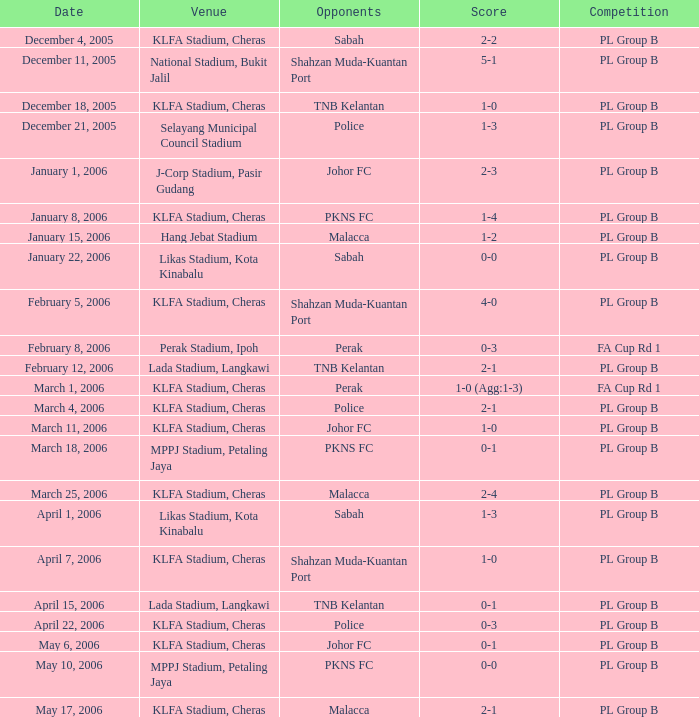Who participated on may 6, 2006? Johor FC. 